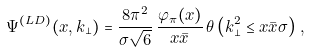<formula> <loc_0><loc_0><loc_500><loc_500>\Psi ^ { ( L D ) } ( x , k _ { \perp } ) = \frac { 8 \pi ^ { 2 } } { \sigma \sqrt { 6 } } \, \frac { \varphi _ { \pi } ( x ) } { x \bar { x } } \, \theta \left ( { k _ { \perp } ^ { 2 } \leq x \bar { x } \sigma } \right ) \, ,</formula> 